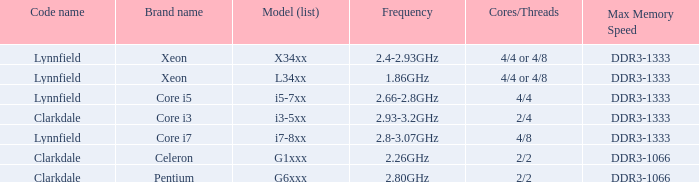What is the maximum memory speed for frequencies between 2.93-3.2ghz? DDR3-1333. 